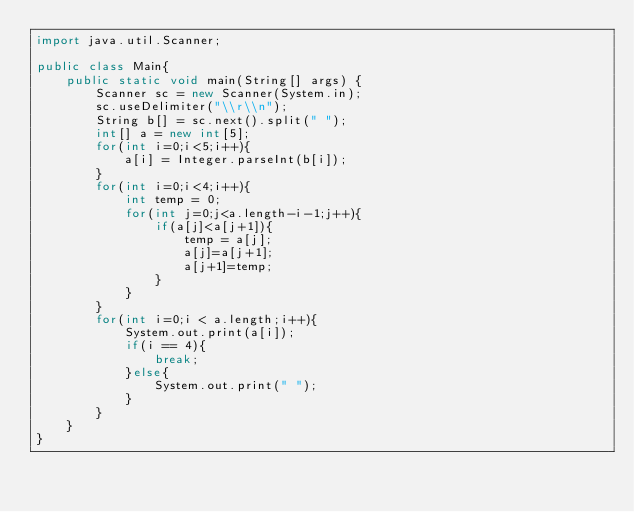<code> <loc_0><loc_0><loc_500><loc_500><_Java_>import java.util.Scanner;

public class Main{
	public static void main(String[] args) {
		Scanner sc = new Scanner(System.in);
		sc.useDelimiter("\\r\\n");
		String b[] = sc.next().split(" ");
		int[] a = new int[5];
		for(int i=0;i<5;i++){
			a[i] = Integer.parseInt(b[i]);
		}
		for(int i=0;i<4;i++){
			int temp = 0;
			for(int j=0;j<a.length-i-1;j++){
				if(a[j]<a[j+1]){
					temp = a[j];
					a[j]=a[j+1];
					a[j+1]=temp;
				}
			}
		}
		for(int i=0;i < a.length;i++){
			System.out.print(a[i]);
			if(i == 4){
				break;
			}else{
				System.out.print(" ");
			}
		}
	}
}</code> 